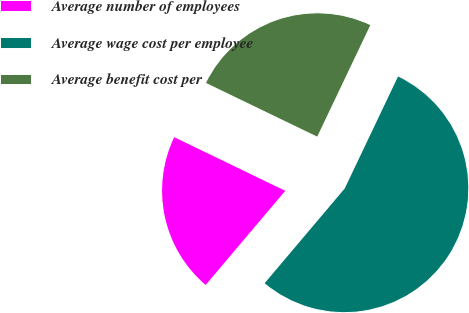Convert chart to OTSL. <chart><loc_0><loc_0><loc_500><loc_500><pie_chart><fcel>Average number of employees<fcel>Average wage cost per employee<fcel>Average benefit cost per<nl><fcel>20.99%<fcel>54.1%<fcel>24.91%<nl></chart> 